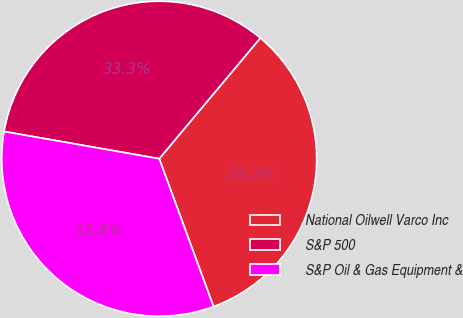<chart> <loc_0><loc_0><loc_500><loc_500><pie_chart><fcel>National Oilwell Varco Inc<fcel>S&P 500<fcel>S&P Oil & Gas Equipment &<nl><fcel>33.3%<fcel>33.33%<fcel>33.37%<nl></chart> 